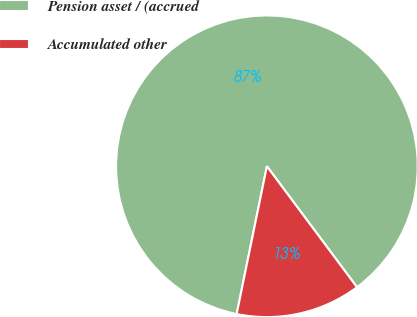Convert chart to OTSL. <chart><loc_0><loc_0><loc_500><loc_500><pie_chart><fcel>Pension asset / (accrued<fcel>Accumulated other<nl><fcel>86.6%<fcel>13.4%<nl></chart> 